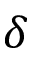Convert formula to latex. <formula><loc_0><loc_0><loc_500><loc_500>\delta</formula> 